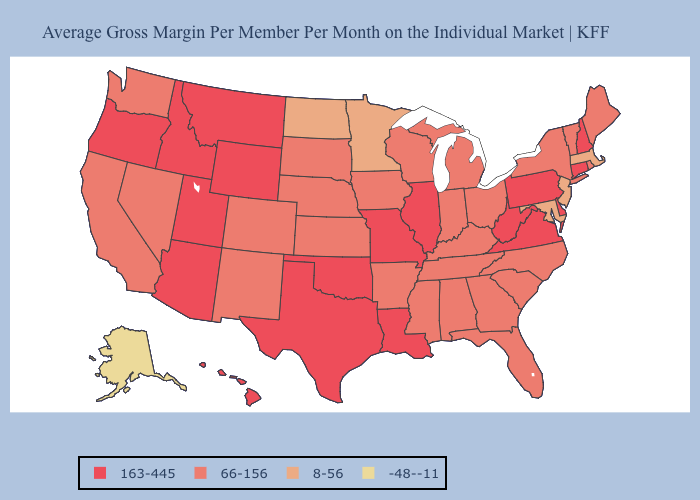Does West Virginia have the lowest value in the USA?
Give a very brief answer. No. Among the states that border Montana , which have the highest value?
Keep it brief. Idaho, Wyoming. Name the states that have a value in the range 163-445?
Answer briefly. Arizona, Connecticut, Delaware, Hawaii, Idaho, Illinois, Louisiana, Missouri, Montana, New Hampshire, Oklahoma, Oregon, Pennsylvania, Texas, Utah, Virginia, West Virginia, Wyoming. Does the map have missing data?
Short answer required. No. Does Pennsylvania have the highest value in the Northeast?
Write a very short answer. Yes. Among the states that border New York , which have the highest value?
Keep it brief. Connecticut, Pennsylvania. What is the lowest value in the South?
Quick response, please. 8-56. What is the highest value in states that border Wisconsin?
Concise answer only. 163-445. What is the highest value in states that border Michigan?
Give a very brief answer. 66-156. Name the states that have a value in the range 66-156?
Write a very short answer. Alabama, Arkansas, California, Colorado, Florida, Georgia, Indiana, Iowa, Kansas, Kentucky, Maine, Michigan, Mississippi, Nebraska, Nevada, New Mexico, New York, North Carolina, Ohio, Rhode Island, South Carolina, South Dakota, Tennessee, Vermont, Washington, Wisconsin. Does the map have missing data?
Short answer required. No. What is the value of West Virginia?
Be succinct. 163-445. Name the states that have a value in the range 66-156?
Answer briefly. Alabama, Arkansas, California, Colorado, Florida, Georgia, Indiana, Iowa, Kansas, Kentucky, Maine, Michigan, Mississippi, Nebraska, Nevada, New Mexico, New York, North Carolina, Ohio, Rhode Island, South Carolina, South Dakota, Tennessee, Vermont, Washington, Wisconsin. Among the states that border Delaware , does Pennsylvania have the lowest value?
Quick response, please. No. Does Alaska have the lowest value in the USA?
Write a very short answer. Yes. 